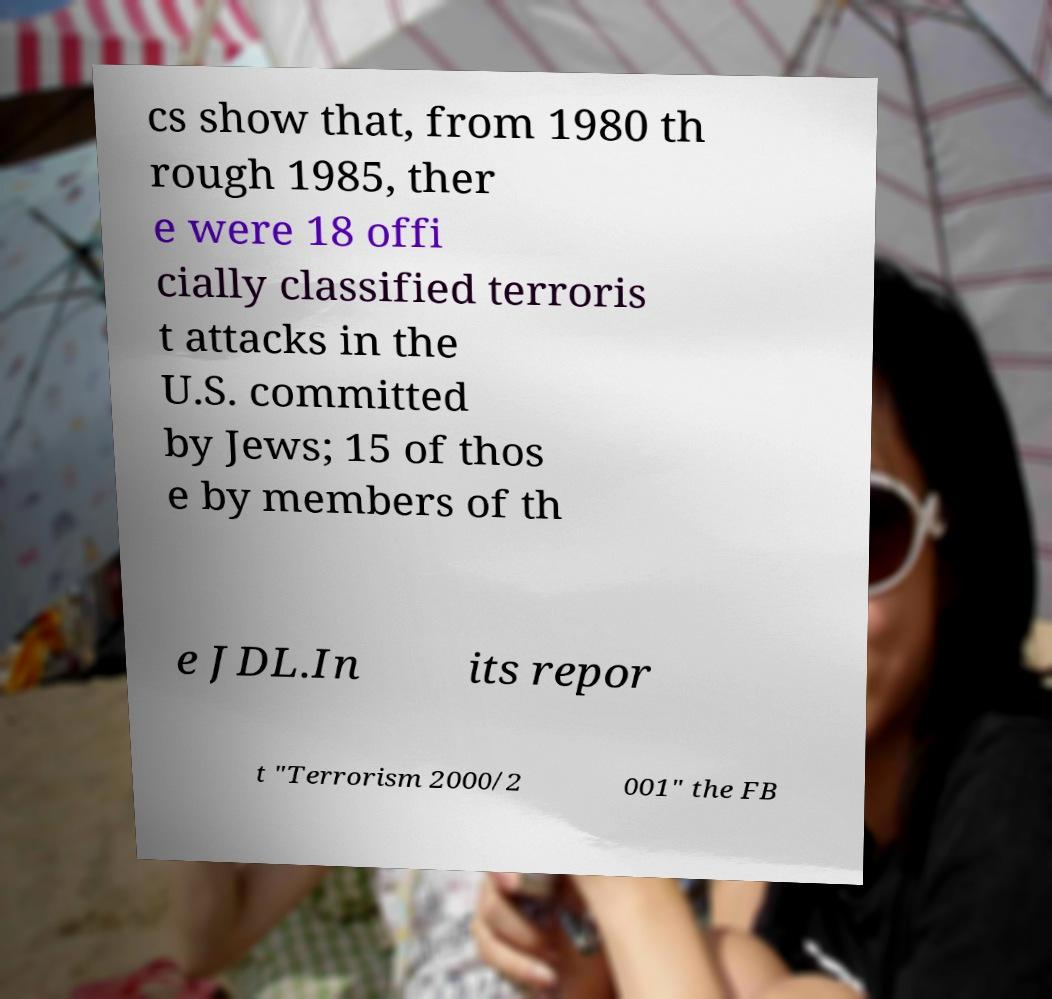What messages or text are displayed in this image? I need them in a readable, typed format. cs show that, from 1980 th rough 1985, ther e were 18 offi cially classified terroris t attacks in the U.S. committed by Jews; 15 of thos e by members of th e JDL.In its repor t "Terrorism 2000/2 001" the FB 